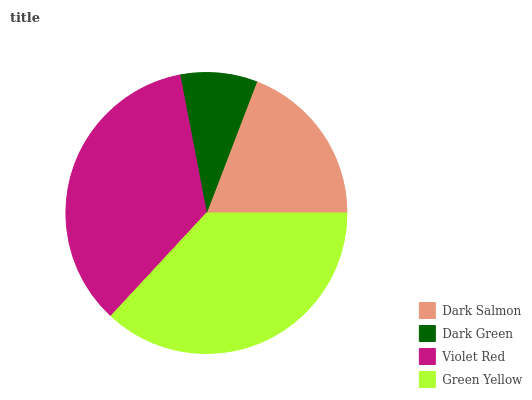Is Dark Green the minimum?
Answer yes or no. Yes. Is Green Yellow the maximum?
Answer yes or no. Yes. Is Violet Red the minimum?
Answer yes or no. No. Is Violet Red the maximum?
Answer yes or no. No. Is Violet Red greater than Dark Green?
Answer yes or no. Yes. Is Dark Green less than Violet Red?
Answer yes or no. Yes. Is Dark Green greater than Violet Red?
Answer yes or no. No. Is Violet Red less than Dark Green?
Answer yes or no. No. Is Violet Red the high median?
Answer yes or no. Yes. Is Dark Salmon the low median?
Answer yes or no. Yes. Is Dark Green the high median?
Answer yes or no. No. Is Green Yellow the low median?
Answer yes or no. No. 